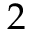<formula> <loc_0><loc_0><loc_500><loc_500>2</formula> 